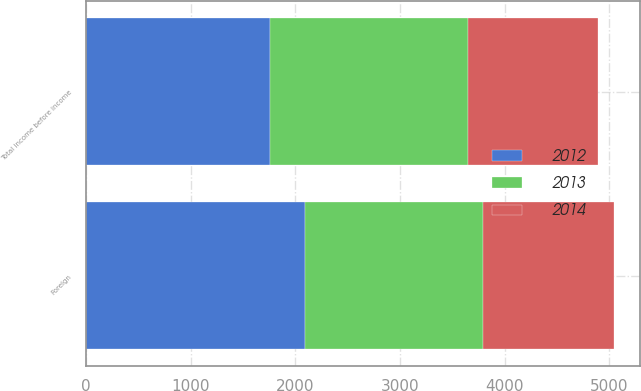Convert chart to OTSL. <chart><loc_0><loc_0><loc_500><loc_500><stacked_bar_chart><ecel><fcel>Foreign<fcel>Total income before income<nl><fcel>2012<fcel>2093<fcel>1761<nl><fcel>2013<fcel>1700<fcel>1884<nl><fcel>2014<fcel>1251<fcel>1251<nl></chart> 